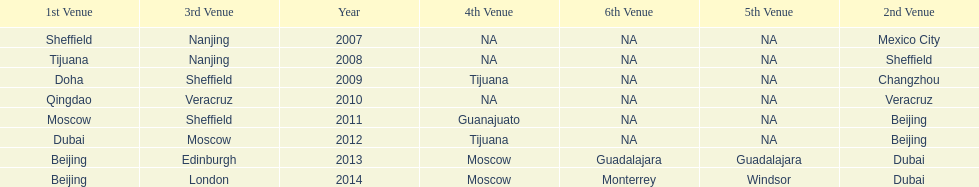Which year had more venues, 2007 or 2012? 2012. 